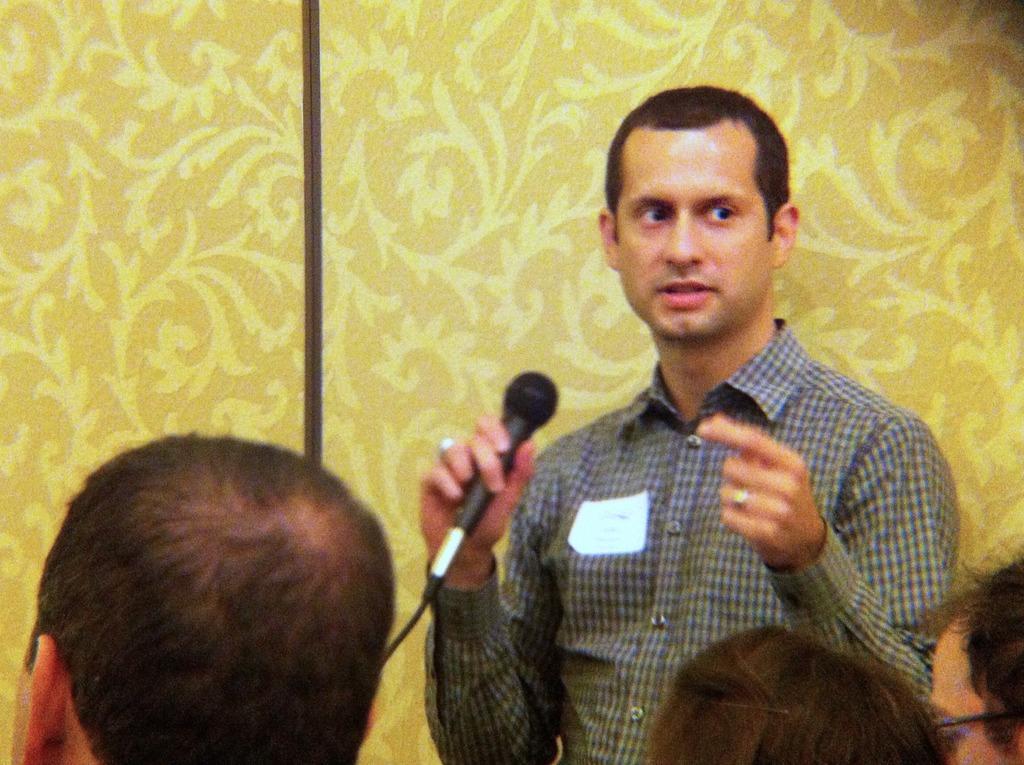In one or two sentences, can you explain what this image depicts? A man with checked shirt is holding a mic. In front of him there are some people are sitting. Behind him there is a yellow color wall. 